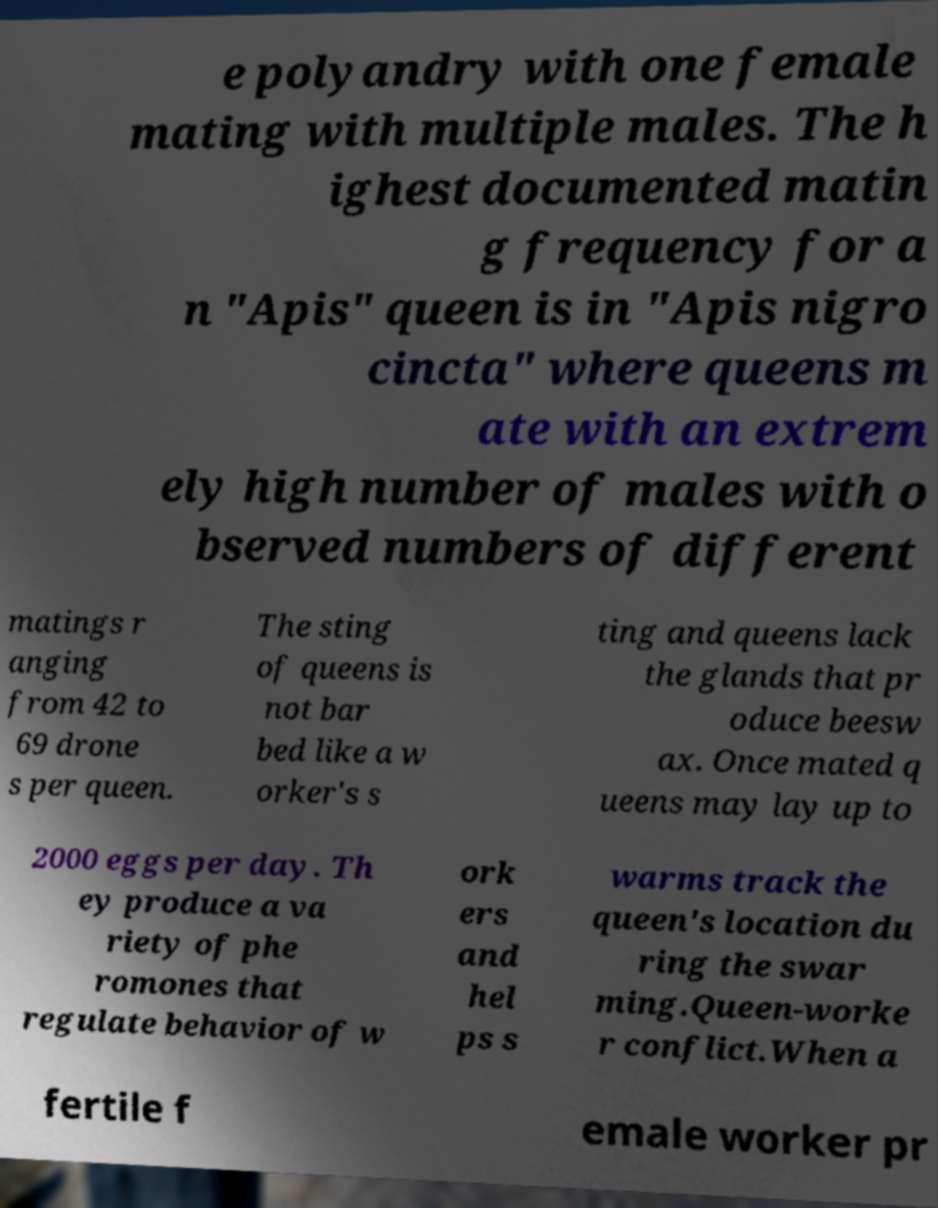Could you assist in decoding the text presented in this image and type it out clearly? e polyandry with one female mating with multiple males. The h ighest documented matin g frequency for a n "Apis" queen is in "Apis nigro cincta" where queens m ate with an extrem ely high number of males with o bserved numbers of different matings r anging from 42 to 69 drone s per queen. The sting of queens is not bar bed like a w orker's s ting and queens lack the glands that pr oduce beesw ax. Once mated q ueens may lay up to 2000 eggs per day. Th ey produce a va riety of phe romones that regulate behavior of w ork ers and hel ps s warms track the queen's location du ring the swar ming.Queen-worke r conflict.When a fertile f emale worker pr 